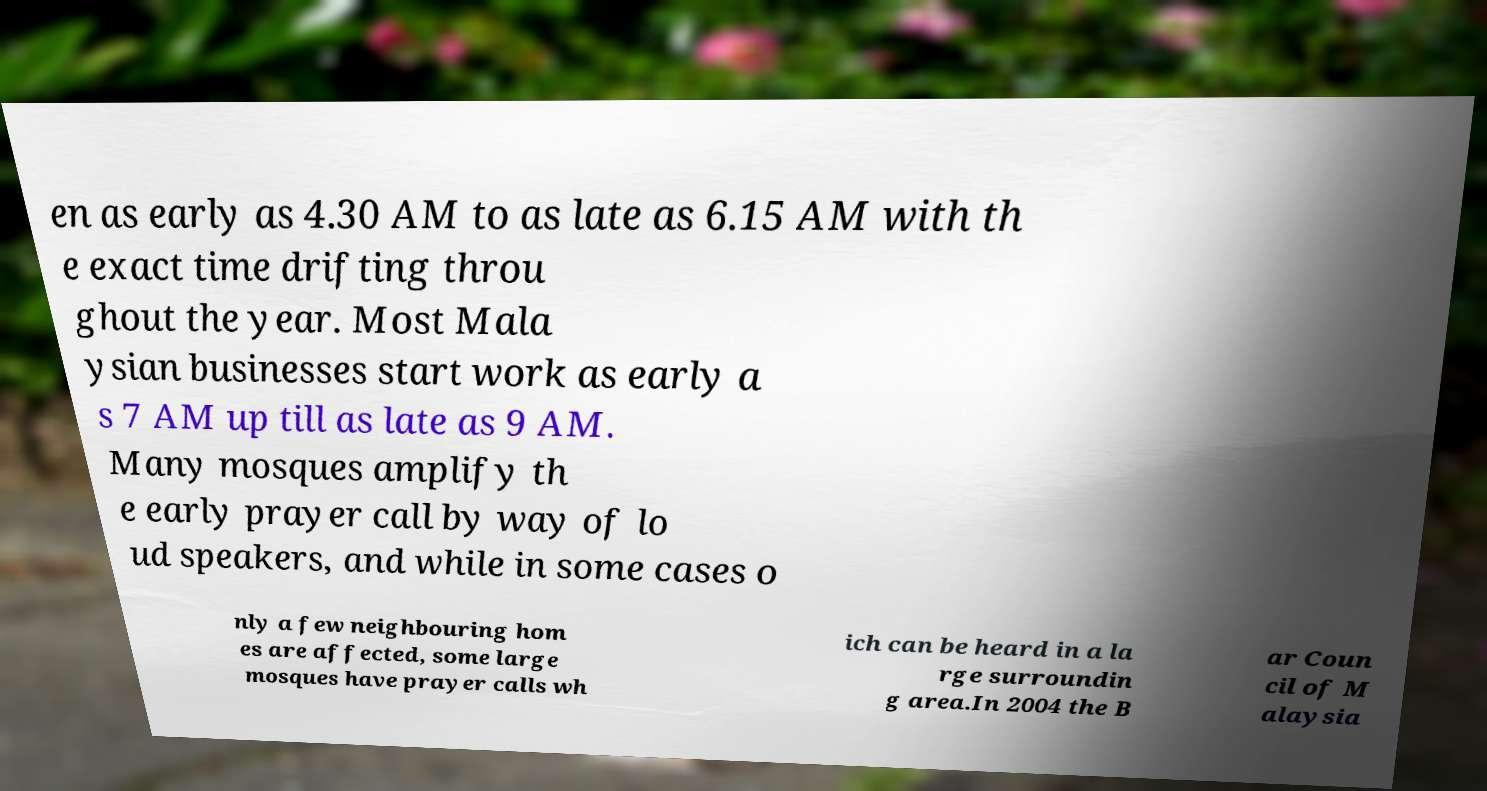I need the written content from this picture converted into text. Can you do that? en as early as 4.30 AM to as late as 6.15 AM with th e exact time drifting throu ghout the year. Most Mala ysian businesses start work as early a s 7 AM up till as late as 9 AM. Many mosques amplify th e early prayer call by way of lo ud speakers, and while in some cases o nly a few neighbouring hom es are affected, some large mosques have prayer calls wh ich can be heard in a la rge surroundin g area.In 2004 the B ar Coun cil of M alaysia 